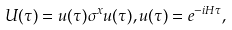Convert formula to latex. <formula><loc_0><loc_0><loc_500><loc_500>U ( \tau ) = u ( \tau ) \sigma ^ { x } u ( \tau ) , u ( \tau ) = e ^ { - i H \tau } ,</formula> 